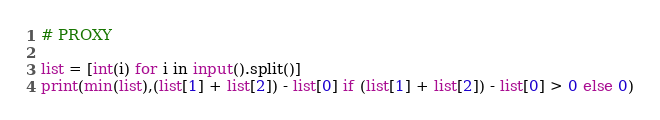<code> <loc_0><loc_0><loc_500><loc_500><_Python_># PROXY

list = [int(i) for i in input().split()]
print(min(list),(list[1] + list[2]) - list[0] if (list[1] + list[2]) - list[0] > 0 else 0)</code> 